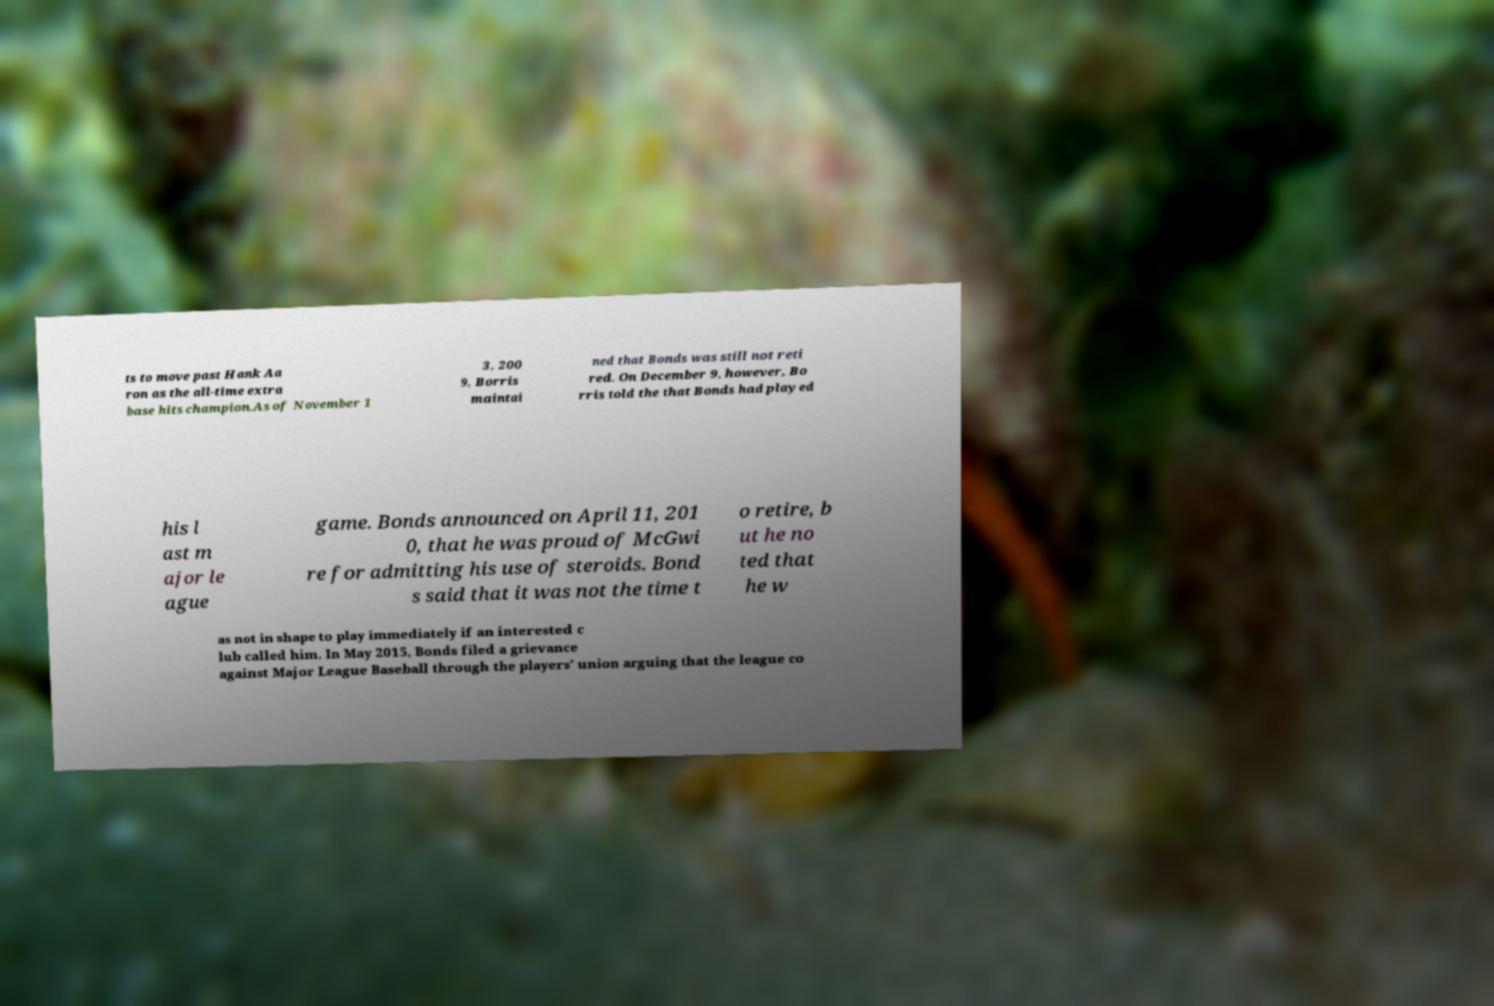I need the written content from this picture converted into text. Can you do that? ts to move past Hank Aa ron as the all-time extra base hits champion.As of November 1 3, 200 9, Borris maintai ned that Bonds was still not reti red. On December 9, however, Bo rris told the that Bonds had played his l ast m ajor le ague game. Bonds announced on April 11, 201 0, that he was proud of McGwi re for admitting his use of steroids. Bond s said that it was not the time t o retire, b ut he no ted that he w as not in shape to play immediately if an interested c lub called him. In May 2015, Bonds filed a grievance against Major League Baseball through the players' union arguing that the league co 